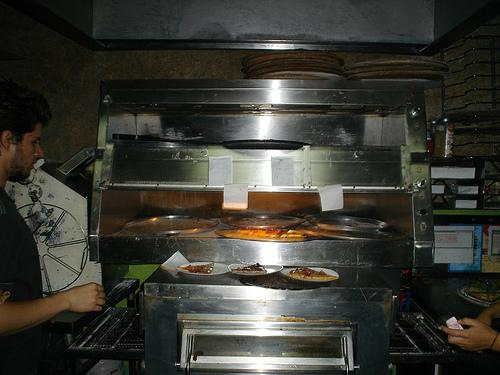Question: where are the people in the photo?
Choices:
A. A theater.
B. An office.
C. A beach.
D. A restaurant.
Answer with the letter. Answer: D Question: what room are the men in the restaurant?
Choices:
A. The kitchen.
B. Dining room.
C. Waiting area.
D. Bathroom.
Answer with the letter. Answer: A Question: what is in the kitchen?
Choices:
A. Stove.
B. Counters.
C. An oven.
D. Table.
Answer with the letter. Answer: C Question: how many plates are in the photo?
Choices:
A. One.
B. Four.
C. Ten.
D. Three.
Answer with the letter. Answer: D 